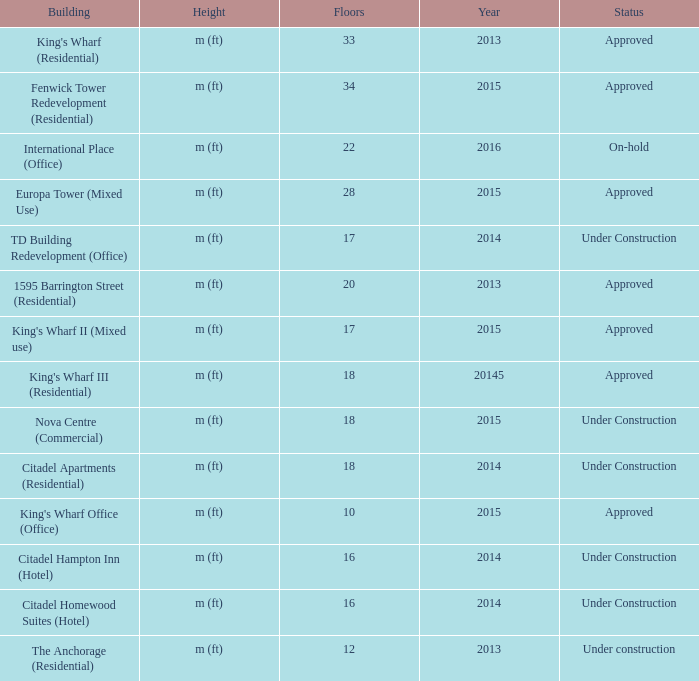What is the status of the building with more than 28 floor and a year of 2013? Approved. 